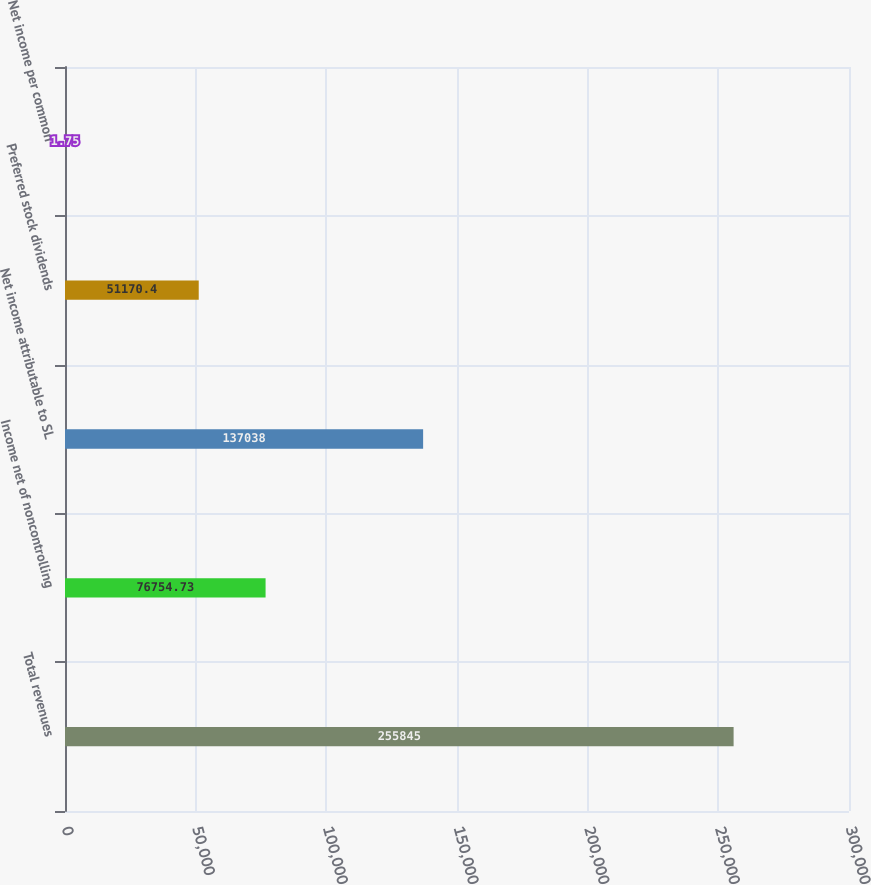Convert chart to OTSL. <chart><loc_0><loc_0><loc_500><loc_500><bar_chart><fcel>Total revenues<fcel>Income net of noncontrolling<fcel>Net income attributable to SL<fcel>Preferred stock dividends<fcel>Net income per common<nl><fcel>255845<fcel>76754.7<fcel>137038<fcel>51170.4<fcel>1.75<nl></chart> 